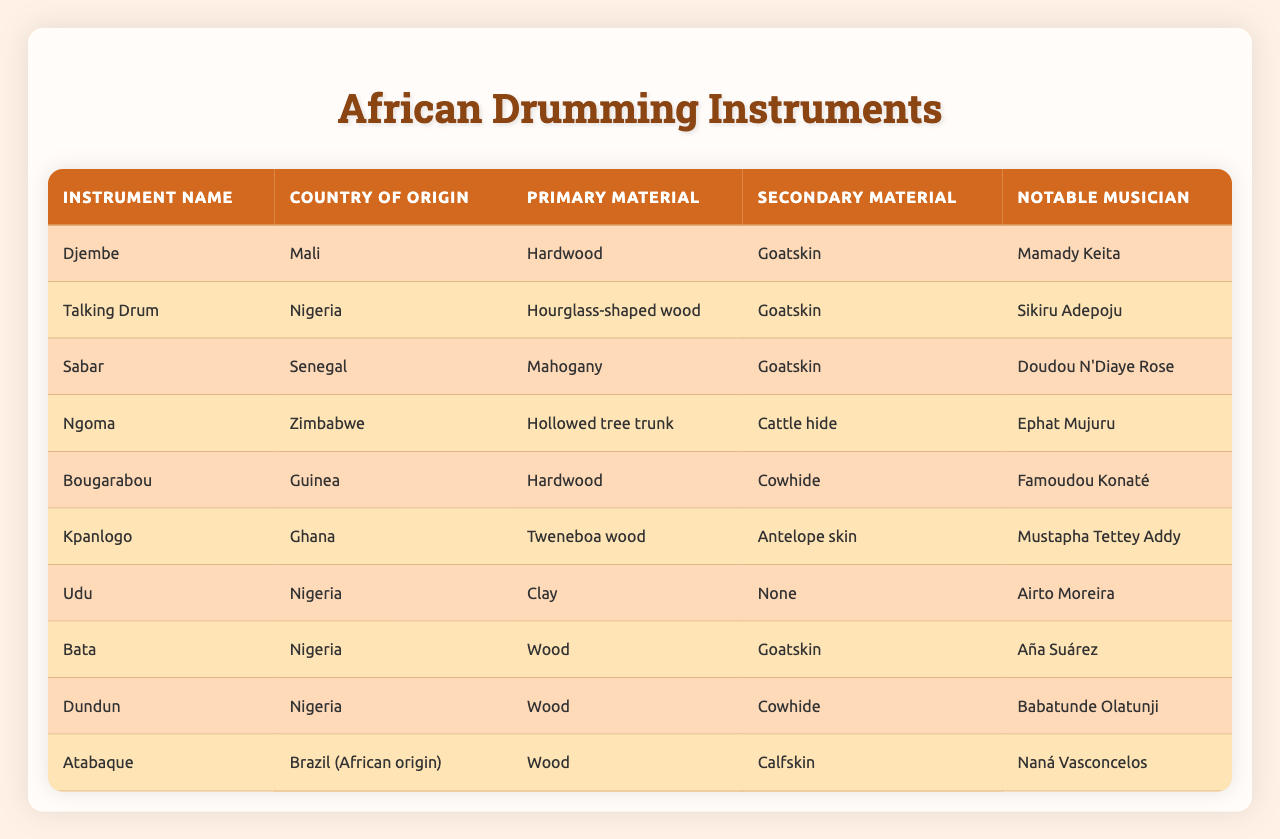What is the primary material of the Djembe? The table shows the primary material for each instrument. For the Djembe, it is listed as Hardwood.
Answer: Hardwood Which country is known for the Sabar? By examining the 'Country of Origin' column for the Sabar, we see that it is from Senegal.
Answer: Senegal Who is the notable musician associated with the Talking Drum? The 'Notable Musician' column provides the names associated with each instrument. The Talking Drum is associated with Sikiru Adepoju.
Answer: Sikiru Adepoju Is the Udu made from wood? The table lists the primary material for the Udu as Clay, which confirms it is not made from wood.
Answer: No How many instruments listed are made of hardwood? From the 'Primary Material' column, I can count the instruments: Djembe and Bougarabou are made of hardwood, totaling 2 instruments.
Answer: 2 Which instrument has an hourglass-shaped wood as its primary material? The 'Instrument Name' column can be cross-referenced with the 'Primary Material' column to find that the Talking Drum matches this description.
Answer: Talking Drum What materials are used for the Ngoma? The table shows that the Ngoma uses 'Hollowed tree trunk' as the primary material and 'Cattle hide' as the secondary material.
Answer: Hollowed tree trunk and Cattle hide Which notable musician plays multiple instruments in Nigeria, based on the table provided? By examining the notable musicians for instruments from Nigeria, we find Sikiru Adepoju (Talking Drum), Aña Suárez (Bata), and Babatunde Olatunji (Dundun). This shows a range of musicians, but no single musician covers multiple instruments listed for Nigeria.
Answer: No single musician for multiple instruments What is the secondary material of the Kpanlogo? Referring to the 'Secondary Material' column for Kpanlogo, it shows Antelope skin as its secondary material.
Answer: Antelope skin Among the listed instruments, which one originates from Brazil and what is its primary material? The table reveals that the Atabaque originates from Brazil, and its primary material is Wood.
Answer: Atabaque, Wood What is the average number of materials used (primary and secondary) among the instruments listed? For each instrument, there are 2 materials (primary and secondary), so with 10 instruments, calculating the average results in 2 total materials: (2*10)/10 = 2.
Answer: 2 